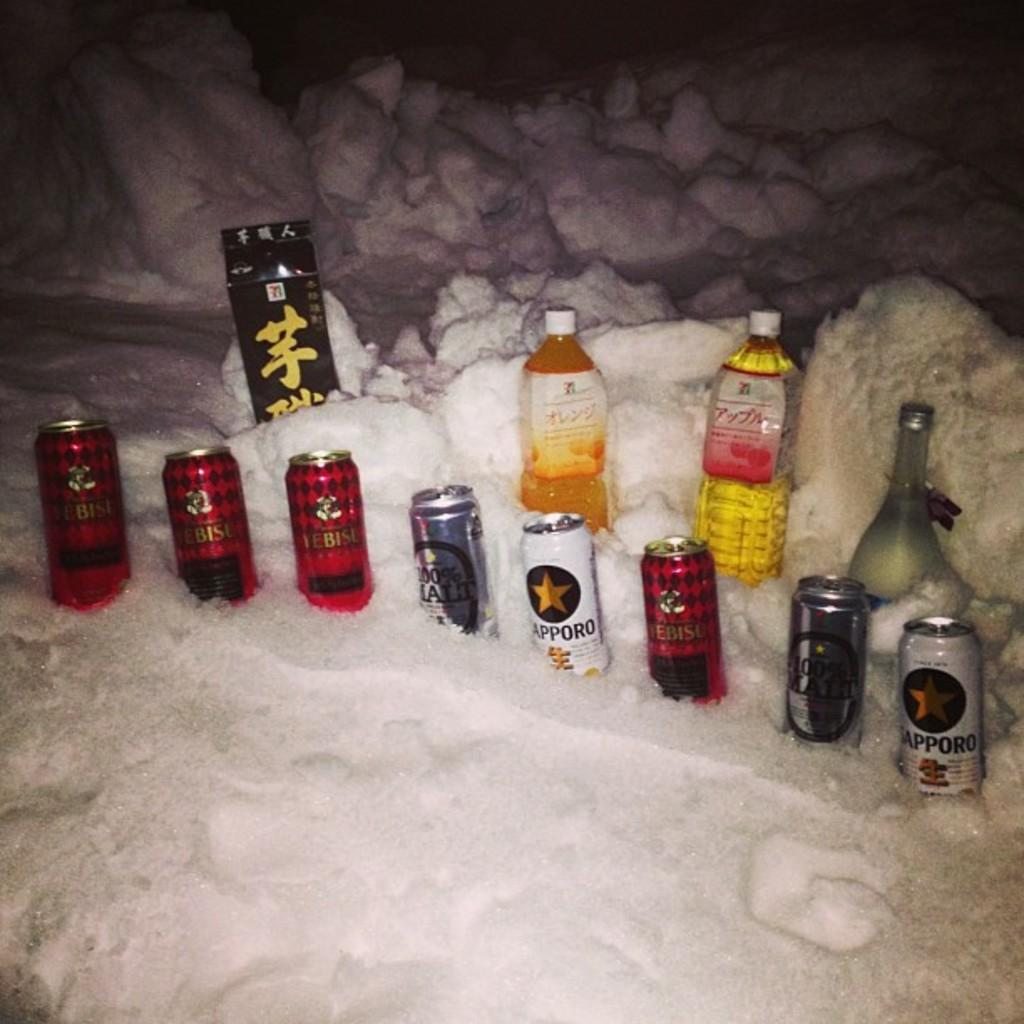<image>
Give a short and clear explanation of the subsequent image. A can of Sapporo sits in a pole if snow in front of two bottles of liquor. 